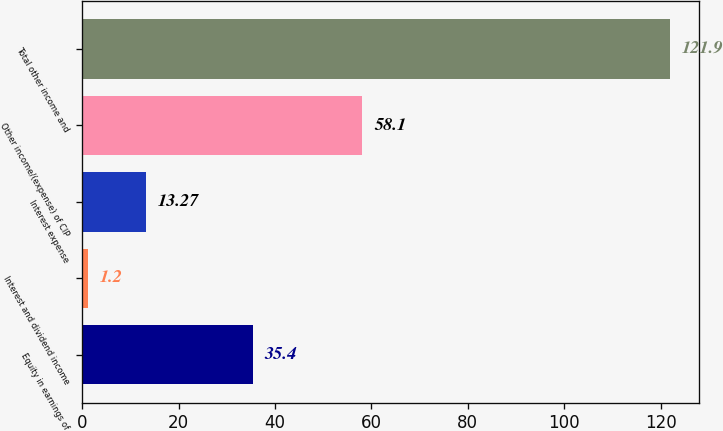<chart> <loc_0><loc_0><loc_500><loc_500><bar_chart><fcel>Equity in earnings of<fcel>Interest and dividend income<fcel>Interest expense<fcel>Other income/(expense) of CIP<fcel>Total other income and<nl><fcel>35.4<fcel>1.2<fcel>13.27<fcel>58.1<fcel>121.9<nl></chart> 